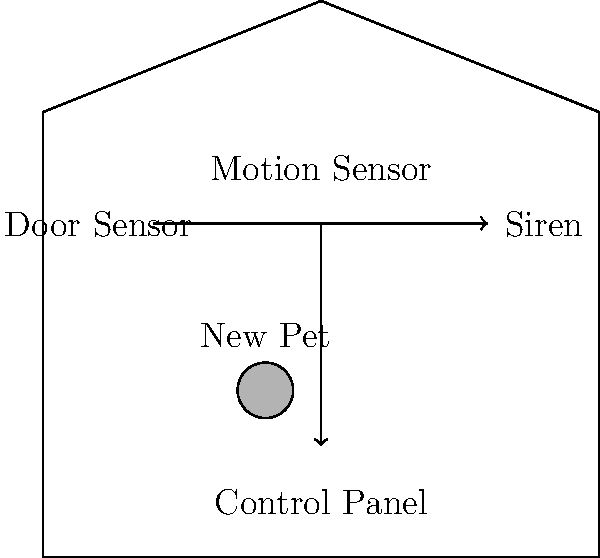In the home security system wiring diagram shown above, which component should be connected first to the control panel to ensure immediate notification in case of a break-in, considering the safety of the family and the new pet? To determine the most crucial component to connect first in this home security system, we need to consider the following steps:

1. Identify the components in the diagram:
   - Motion Sensor
   - Control Panel
   - Siren
   - Door Sensor

2. Analyze the purpose of each component:
   - Motion Sensor: Detects movement inside the house
   - Control Panel: Central unit that processes information from sensors
   - Siren: Produces an audible alarm
   - Door Sensor: Detects when a door is opened

3. Consider the safety priorities:
   - Immediate notification of a break-in
   - Protection of the family and new pet

4. Evaluate the effectiveness of each component for immediate notification:
   - Motion Sensor: Detects intruders after they've entered the house
   - Siren: Alerts after the system has been triggered
   - Door Sensor: Detects the initial point of entry

5. Conclusion:
   The Door Sensor should be connected first to the control panel. It provides the earliest possible detection of a break-in by identifying when an entry point is breached. This allows for immediate notification and gives the family and pet more time to react or seek safety.
Answer: Door Sensor 